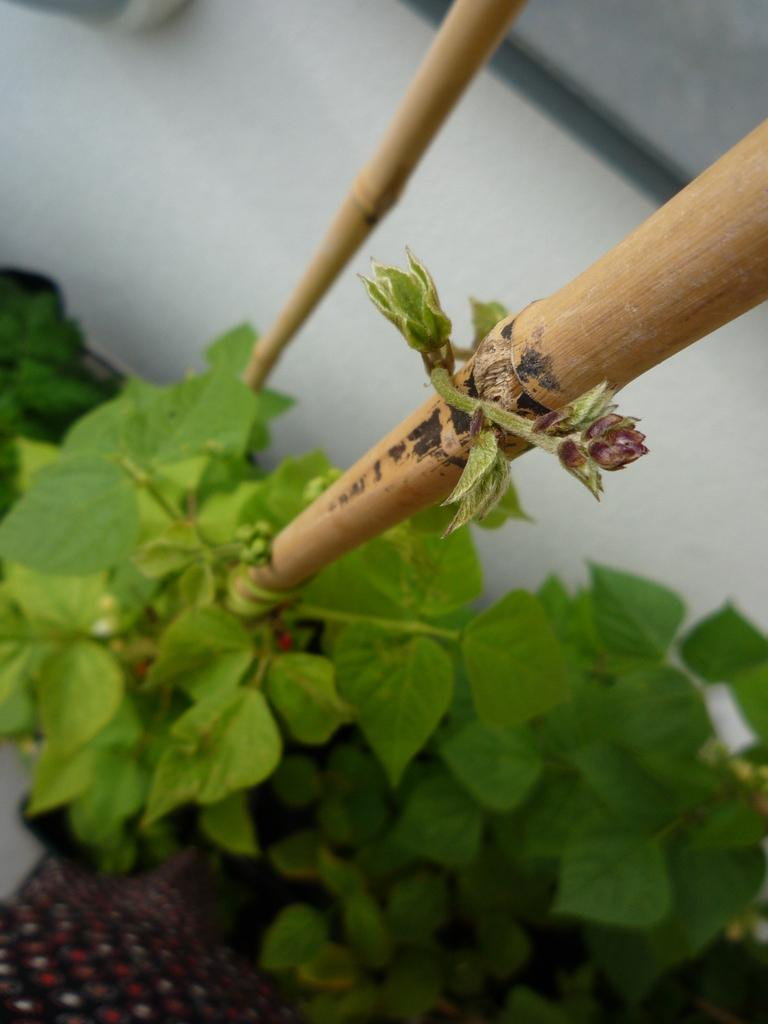What objects are present in the image that resemble long, thin rods? There are two sticks in the image. What is the color of the sticks? The sticks are brown in color. What type of living organisms can be seen in the image? There are plants in the image. What is the color of the plants? The plants are green in color. What can be seen in the background of the image? There is a white wall in the background of the image. What type of leather material can be seen in the image? There is no leather material present in the image. What arithmetic problem is being solved by the plants in the image? The plants in the image are not solving any arithmetic problems; they are simply plants. 